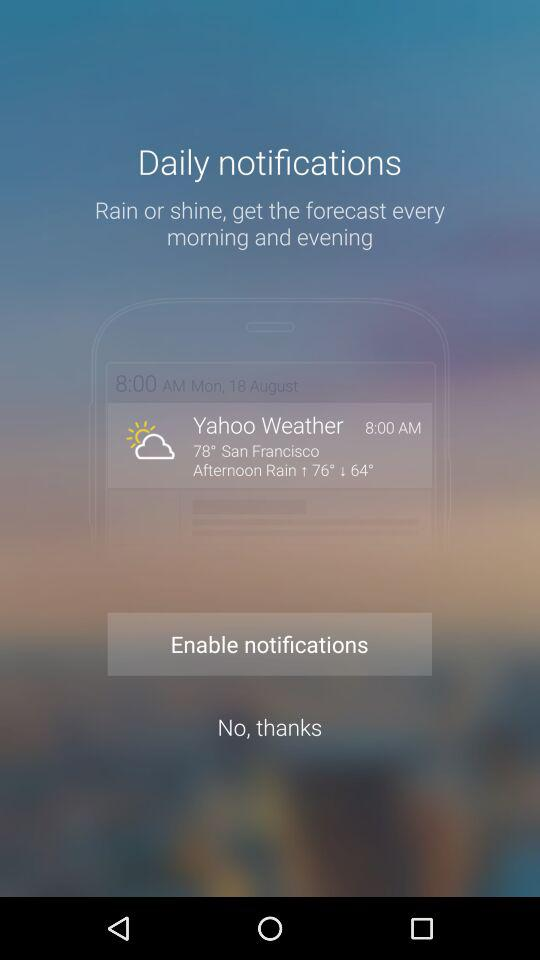When does the sun set in San Francisco?
When the provided information is insufficient, respond with <no answer>. <no answer> 